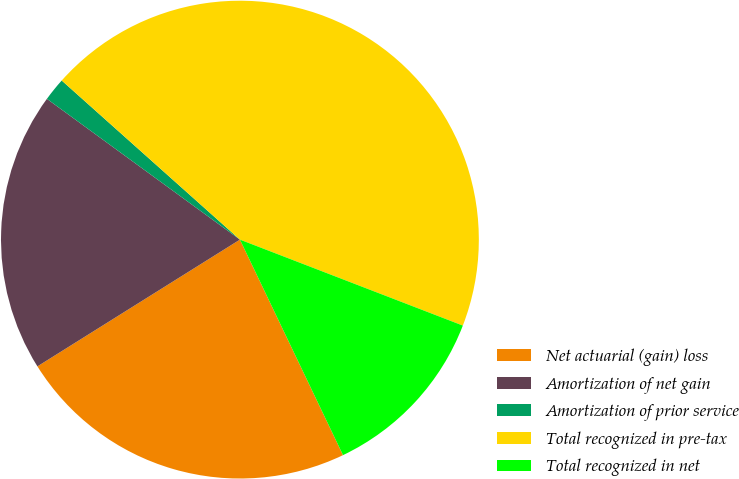Convert chart to OTSL. <chart><loc_0><loc_0><loc_500><loc_500><pie_chart><fcel>Net actuarial (gain) loss<fcel>Amortization of net gain<fcel>Amortization of prior service<fcel>Total recognized in pre-tax<fcel>Total recognized in net<nl><fcel>23.2%<fcel>18.93%<fcel>1.57%<fcel>44.26%<fcel>12.04%<nl></chart> 